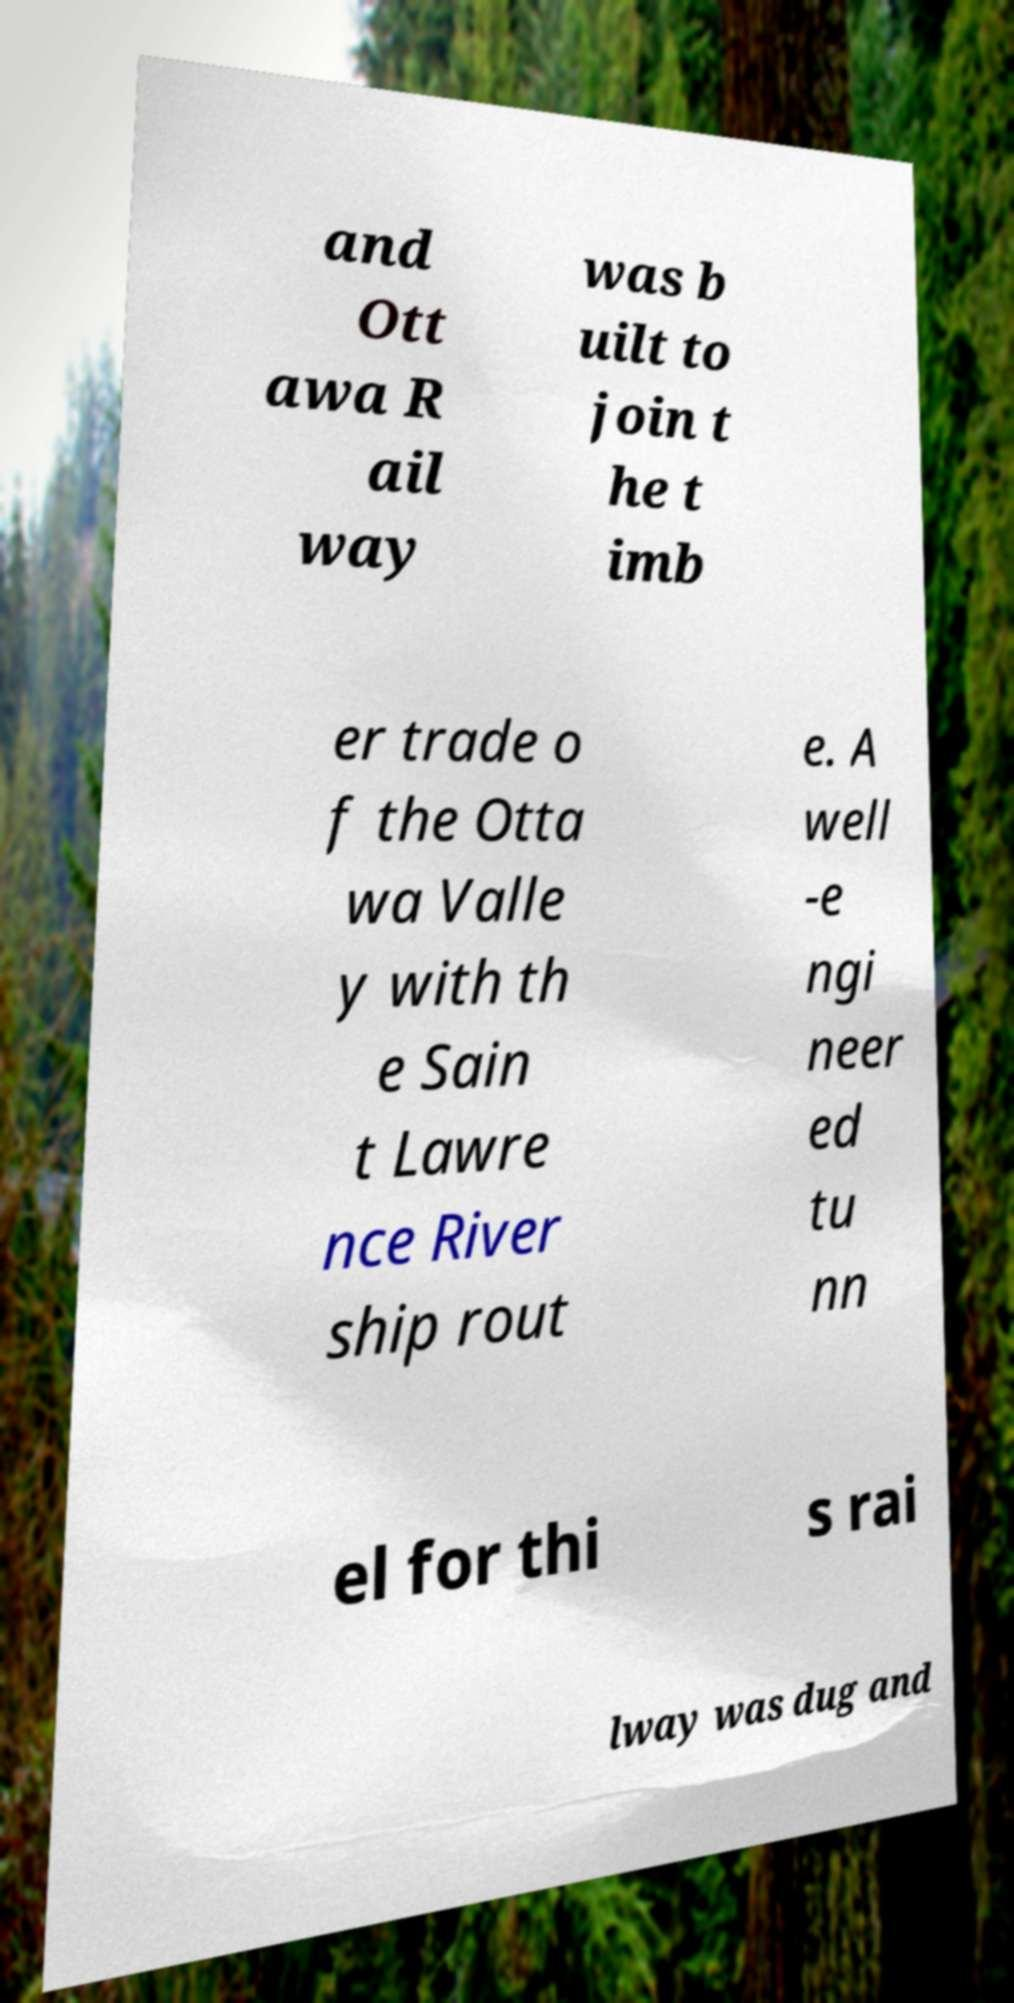Please identify and transcribe the text found in this image. and Ott awa R ail way was b uilt to join t he t imb er trade o f the Otta wa Valle y with th e Sain t Lawre nce River ship rout e. A well -e ngi neer ed tu nn el for thi s rai lway was dug and 